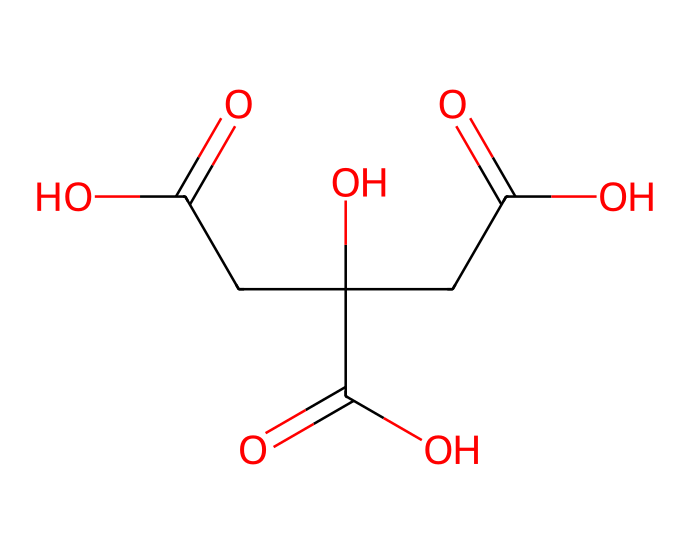What is the name of this chemical? The SMILES representation shows the structure pertaining to citric acid, which is a well-known organic acid.
Answer: citric acid How many carboxylic acid groups are present in citric acid? Inspecting its structure, we can identify three -COOH groups, typical of citric acid.
Answer: three What is the total number of oxygen atoms in citric acid? Counting the oxygen atoms in the three carboxylic acid groups and one from the central carbon, we find a total of six oxygen atoms.
Answer: six What role does citric acid play in preserving food? Citric acid acts as a preservative by lowering pH and inhibiting microbial growth, making it effective in traditional food preservation.
Answer: preservative How does citric acid contribute to the sour taste in foods? The presence of the carboxylic acid functional groups in citric acid is responsible for its sour flavor, as acids typically impart acidity which translates to sourness.
Answer: sourness What type of chemical is citric acid classified as? Citric acid is classified as a weak organic acid due to its incomplete ionization in water, compared to strong acids.
Answer: weak organic acid Which traditional Lithuanian dish commonly uses citric acid as a preservative? Citric acid is often used in pickled vegetables and preserves in Lithuanian cuisine.
Answer: pickled vegetables 